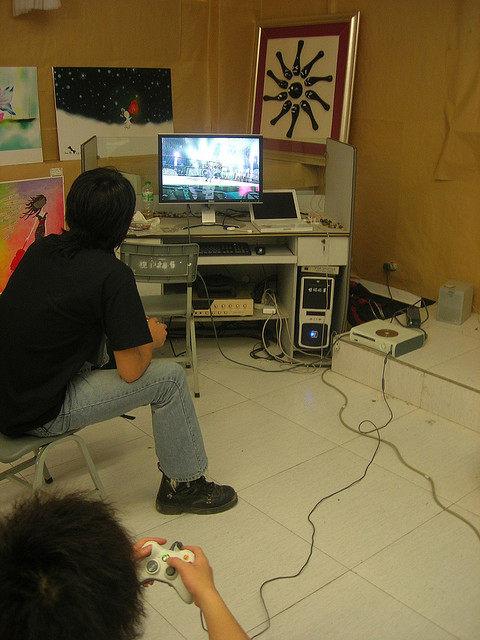What's happening in the scene? Two individuals are engaged in playing a video game. One person is seated on a chair facing a PC monitor while the other holds a game controller, indicating active gameplay. The setup includes an organized computer desk with various connected peripherals, such as speakers and game consoles. The background showcases a wall adorned with framed artwork, adding a touch of creativity to the scene. 